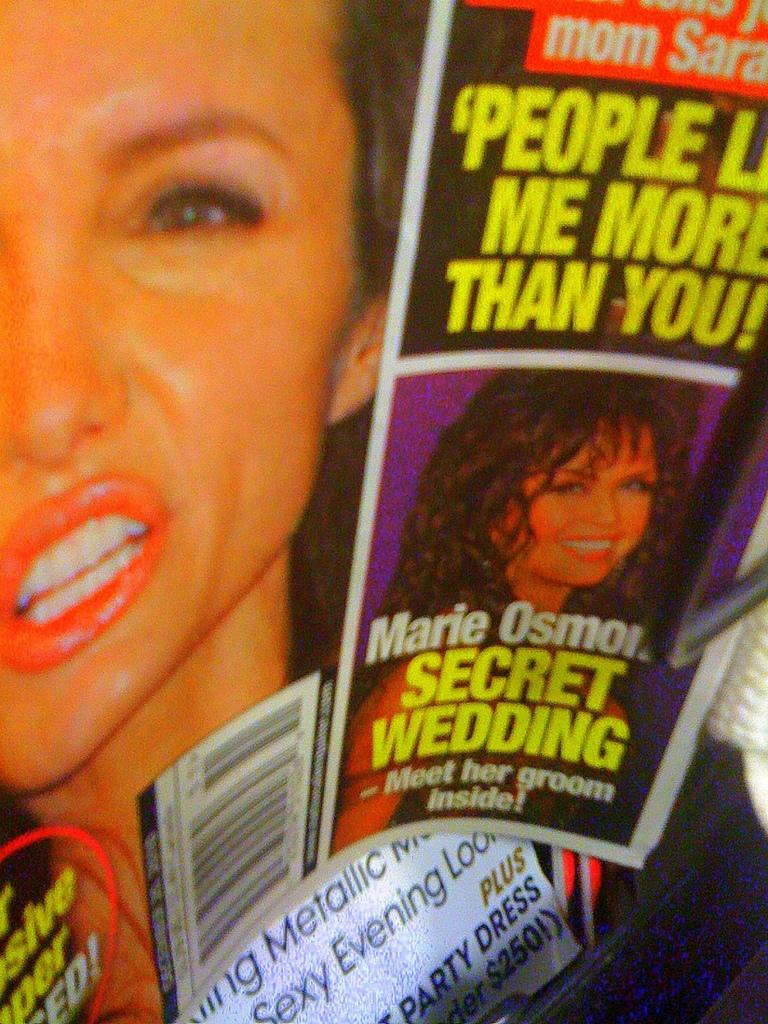What is present on the posters in the image? The posters have text and images on them. Can you describe the content of the posters? The posters have text and images, but the specific content cannot be determined from the provided facts. What type of bushes can be seen growing near the posters in the image? There is no mention of bushes in the provided facts, so it cannot be determined if any bushes are present in the image. 